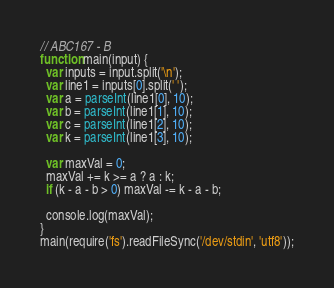<code> <loc_0><loc_0><loc_500><loc_500><_JavaScript_>// ABC167 - B
function main(input) {
  var inputs = input.split('\n');
  var line1 = inputs[0].split(' ');
  var a = parseInt(line1[0], 10);
  var b = parseInt(line1[1], 10);
  var c = parseInt(line1[2], 10);
  var k = parseInt(line1[3], 10);

  var maxVal = 0;
  maxVal += k >= a ? a : k;
  if (k - a - b > 0) maxVal -= k - a - b;

  console.log(maxVal);
}
main(require('fs').readFileSync('/dev/stdin', 'utf8'));
</code> 